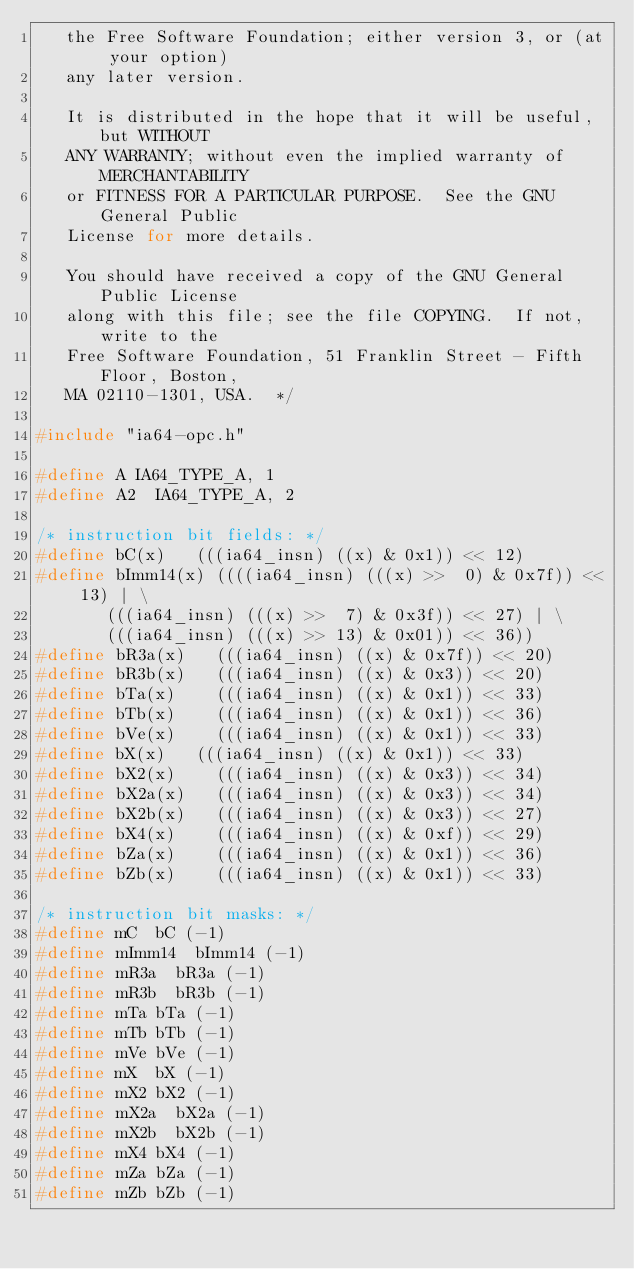<code> <loc_0><loc_0><loc_500><loc_500><_C_>   the Free Software Foundation; either version 3, or (at your option)
   any later version.

   It is distributed in the hope that it will be useful, but WITHOUT
   ANY WARRANTY; without even the implied warranty of MERCHANTABILITY
   or FITNESS FOR A PARTICULAR PURPOSE.  See the GNU General Public
   License for more details.

   You should have received a copy of the GNU General Public License
   along with this file; see the file COPYING.  If not, write to the
   Free Software Foundation, 51 Franklin Street - Fifth Floor, Boston,
   MA 02110-1301, USA.  */

#include "ia64-opc.h"

#define A	IA64_TYPE_A, 1
#define A2	IA64_TYPE_A, 2

/* instruction bit fields: */
#define bC(x)		(((ia64_insn) ((x) & 0x1)) << 12)
#define bImm14(x)	((((ia64_insn) (((x) >>  0) & 0x7f)) << 13) | \
			 (((ia64_insn) (((x) >>  7) & 0x3f)) << 27) | \
			 (((ia64_insn) (((x) >> 13) & 0x01)) << 36))
#define bR3a(x)		(((ia64_insn) ((x) & 0x7f)) << 20)
#define bR3b(x)		(((ia64_insn) ((x) & 0x3)) << 20)
#define bTa(x)		(((ia64_insn) ((x) & 0x1)) << 33)
#define bTb(x)		(((ia64_insn) ((x) & 0x1)) << 36)
#define bVe(x)		(((ia64_insn) ((x) & 0x1)) << 33)
#define bX(x)		(((ia64_insn) ((x) & 0x1)) << 33)
#define bX2(x)		(((ia64_insn) ((x) & 0x3)) << 34)
#define bX2a(x)		(((ia64_insn) ((x) & 0x3)) << 34)
#define bX2b(x)		(((ia64_insn) ((x) & 0x3)) << 27)
#define bX4(x)		(((ia64_insn) ((x) & 0xf)) << 29)
#define bZa(x)		(((ia64_insn) ((x) & 0x1)) << 36)
#define bZb(x)		(((ia64_insn) ((x) & 0x1)) << 33)

/* instruction bit masks: */
#define mC	bC (-1)
#define mImm14	bImm14 (-1)
#define mR3a	bR3a (-1)
#define mR3b	bR3b (-1)
#define mTa	bTa (-1)
#define mTb	bTb (-1)
#define mVe	bVe (-1)
#define mX	bX (-1)
#define mX2	bX2 (-1)
#define mX2a	bX2a (-1)
#define mX2b	bX2b (-1)
#define mX4	bX4 (-1)
#define mZa	bZa (-1)
#define mZb	bZb (-1)
</code> 